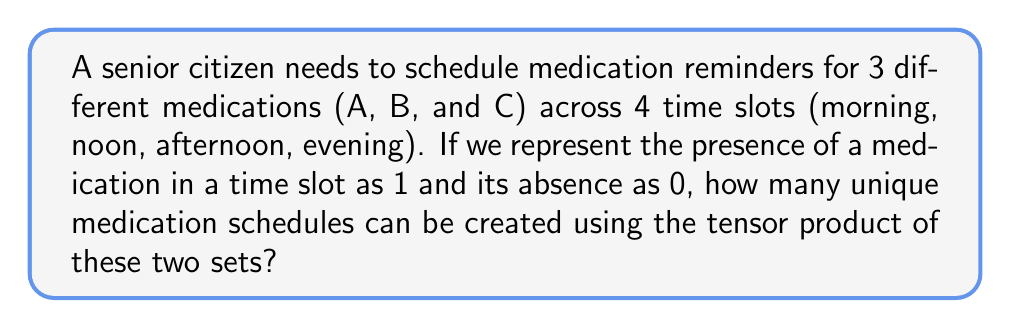What is the answer to this math problem? Let's approach this step-by-step:

1) First, we need to define our two sets:
   - Medications: $M = \{A, B, C\}$ (3 elements)
   - Time slots: $T = \{morning, noon, afternoon, evening\}$ (4 elements)

2) The tensor product of these sets will create all possible combinations of medications and time slots. We can represent this as:

   $M \otimes T$

3) In tensor product, each element of the first set is combined with each element of the second set. The number of elements in the resulting set is the product of the number of elements in the original sets:

   $|M \otimes T| = |M| \times |T| = 3 \times 4 = 12$

4) Now, for each of these 12 combinations, we have two possibilities: the medication is taken (1) or not taken (0) in that time slot.

5) To find the total number of unique schedules, we need to calculate $2^{12}$, as each of the 12 positions can be either 0 or 1.

6) Therefore, the number of unique schedules is:

   $2^{12} = 4096$

This represents all possible ways to schedule 3 medications across 4 time slots.
Answer: $2^{12} = 4096$ 